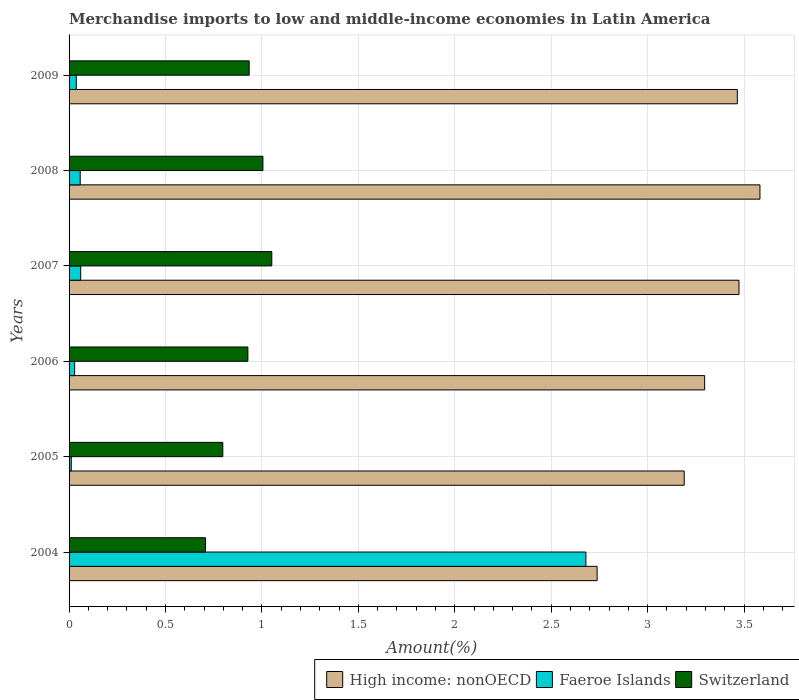How many different coloured bars are there?
Offer a very short reply. 3. Are the number of bars on each tick of the Y-axis equal?
Make the answer very short. Yes. How many bars are there on the 6th tick from the bottom?
Your response must be concise. 3. What is the percentage of amount earned from merchandise imports in Faeroe Islands in 2006?
Ensure brevity in your answer.  0.03. Across all years, what is the maximum percentage of amount earned from merchandise imports in Faeroe Islands?
Ensure brevity in your answer.  2.68. Across all years, what is the minimum percentage of amount earned from merchandise imports in Switzerland?
Ensure brevity in your answer.  0.71. What is the total percentage of amount earned from merchandise imports in Faeroe Islands in the graph?
Provide a succinct answer. 2.88. What is the difference between the percentage of amount earned from merchandise imports in High income: nonOECD in 2004 and that in 2008?
Offer a terse response. -0.84. What is the difference between the percentage of amount earned from merchandise imports in Switzerland in 2004 and the percentage of amount earned from merchandise imports in Faeroe Islands in 2009?
Make the answer very short. 0.67. What is the average percentage of amount earned from merchandise imports in Faeroe Islands per year?
Give a very brief answer. 0.48. In the year 2008, what is the difference between the percentage of amount earned from merchandise imports in Switzerland and percentage of amount earned from merchandise imports in Faeroe Islands?
Provide a short and direct response. 0.95. What is the ratio of the percentage of amount earned from merchandise imports in High income: nonOECD in 2004 to that in 2008?
Ensure brevity in your answer.  0.76. Is the percentage of amount earned from merchandise imports in Switzerland in 2004 less than that in 2008?
Ensure brevity in your answer.  Yes. What is the difference between the highest and the second highest percentage of amount earned from merchandise imports in Faeroe Islands?
Your response must be concise. 2.62. What is the difference between the highest and the lowest percentage of amount earned from merchandise imports in Faeroe Islands?
Provide a succinct answer. 2.67. What does the 3rd bar from the top in 2009 represents?
Give a very brief answer. High income: nonOECD. What does the 3rd bar from the bottom in 2006 represents?
Offer a very short reply. Switzerland. Is it the case that in every year, the sum of the percentage of amount earned from merchandise imports in Switzerland and percentage of amount earned from merchandise imports in Faeroe Islands is greater than the percentage of amount earned from merchandise imports in High income: nonOECD?
Offer a very short reply. No. How many bars are there?
Your response must be concise. 18. Are all the bars in the graph horizontal?
Your response must be concise. Yes. What is the difference between two consecutive major ticks on the X-axis?
Your response must be concise. 0.5. Does the graph contain any zero values?
Keep it short and to the point. No. Does the graph contain grids?
Provide a short and direct response. Yes. How many legend labels are there?
Your answer should be compact. 3. What is the title of the graph?
Your response must be concise. Merchandise imports to low and middle-income economies in Latin America. Does "Madagascar" appear as one of the legend labels in the graph?
Ensure brevity in your answer.  No. What is the label or title of the X-axis?
Ensure brevity in your answer.  Amount(%). What is the Amount(%) of High income: nonOECD in 2004?
Make the answer very short. 2.74. What is the Amount(%) of Faeroe Islands in 2004?
Your response must be concise. 2.68. What is the Amount(%) of Switzerland in 2004?
Offer a very short reply. 0.71. What is the Amount(%) of High income: nonOECD in 2005?
Make the answer very short. 3.19. What is the Amount(%) in Faeroe Islands in 2005?
Provide a succinct answer. 0.01. What is the Amount(%) of Switzerland in 2005?
Your response must be concise. 0.8. What is the Amount(%) in High income: nonOECD in 2006?
Provide a succinct answer. 3.3. What is the Amount(%) of Faeroe Islands in 2006?
Make the answer very short. 0.03. What is the Amount(%) in Switzerland in 2006?
Give a very brief answer. 0.93. What is the Amount(%) of High income: nonOECD in 2007?
Your response must be concise. 3.47. What is the Amount(%) in Faeroe Islands in 2007?
Provide a short and direct response. 0.06. What is the Amount(%) of Switzerland in 2007?
Make the answer very short. 1.05. What is the Amount(%) of High income: nonOECD in 2008?
Your answer should be very brief. 3.58. What is the Amount(%) in Faeroe Islands in 2008?
Keep it short and to the point. 0.06. What is the Amount(%) of Switzerland in 2008?
Give a very brief answer. 1.01. What is the Amount(%) in High income: nonOECD in 2009?
Offer a terse response. 3.47. What is the Amount(%) in Faeroe Islands in 2009?
Make the answer very short. 0.04. What is the Amount(%) of Switzerland in 2009?
Offer a terse response. 0.93. Across all years, what is the maximum Amount(%) of High income: nonOECD?
Offer a terse response. 3.58. Across all years, what is the maximum Amount(%) in Faeroe Islands?
Keep it short and to the point. 2.68. Across all years, what is the maximum Amount(%) in Switzerland?
Your response must be concise. 1.05. Across all years, what is the minimum Amount(%) of High income: nonOECD?
Offer a terse response. 2.74. Across all years, what is the minimum Amount(%) in Faeroe Islands?
Your response must be concise. 0.01. Across all years, what is the minimum Amount(%) of Switzerland?
Keep it short and to the point. 0.71. What is the total Amount(%) in High income: nonOECD in the graph?
Offer a terse response. 19.75. What is the total Amount(%) in Faeroe Islands in the graph?
Your answer should be compact. 2.88. What is the total Amount(%) of Switzerland in the graph?
Your response must be concise. 5.42. What is the difference between the Amount(%) of High income: nonOECD in 2004 and that in 2005?
Give a very brief answer. -0.45. What is the difference between the Amount(%) of Faeroe Islands in 2004 and that in 2005?
Give a very brief answer. 2.67. What is the difference between the Amount(%) in Switzerland in 2004 and that in 2005?
Your answer should be very brief. -0.09. What is the difference between the Amount(%) of High income: nonOECD in 2004 and that in 2006?
Ensure brevity in your answer.  -0.56. What is the difference between the Amount(%) in Faeroe Islands in 2004 and that in 2006?
Ensure brevity in your answer.  2.65. What is the difference between the Amount(%) in Switzerland in 2004 and that in 2006?
Your response must be concise. -0.22. What is the difference between the Amount(%) of High income: nonOECD in 2004 and that in 2007?
Offer a terse response. -0.74. What is the difference between the Amount(%) of Faeroe Islands in 2004 and that in 2007?
Your response must be concise. 2.62. What is the difference between the Amount(%) in Switzerland in 2004 and that in 2007?
Make the answer very short. -0.34. What is the difference between the Amount(%) of High income: nonOECD in 2004 and that in 2008?
Offer a very short reply. -0.84. What is the difference between the Amount(%) of Faeroe Islands in 2004 and that in 2008?
Offer a very short reply. 2.62. What is the difference between the Amount(%) in Switzerland in 2004 and that in 2008?
Provide a succinct answer. -0.3. What is the difference between the Amount(%) of High income: nonOECD in 2004 and that in 2009?
Keep it short and to the point. -0.73. What is the difference between the Amount(%) in Faeroe Islands in 2004 and that in 2009?
Keep it short and to the point. 2.64. What is the difference between the Amount(%) of Switzerland in 2004 and that in 2009?
Make the answer very short. -0.23. What is the difference between the Amount(%) of High income: nonOECD in 2005 and that in 2006?
Give a very brief answer. -0.11. What is the difference between the Amount(%) in Faeroe Islands in 2005 and that in 2006?
Make the answer very short. -0.02. What is the difference between the Amount(%) of Switzerland in 2005 and that in 2006?
Your answer should be very brief. -0.13. What is the difference between the Amount(%) in High income: nonOECD in 2005 and that in 2007?
Offer a terse response. -0.28. What is the difference between the Amount(%) in Faeroe Islands in 2005 and that in 2007?
Offer a terse response. -0.05. What is the difference between the Amount(%) of Switzerland in 2005 and that in 2007?
Give a very brief answer. -0.25. What is the difference between the Amount(%) of High income: nonOECD in 2005 and that in 2008?
Offer a very short reply. -0.39. What is the difference between the Amount(%) of Faeroe Islands in 2005 and that in 2008?
Provide a short and direct response. -0.05. What is the difference between the Amount(%) in Switzerland in 2005 and that in 2008?
Offer a very short reply. -0.21. What is the difference between the Amount(%) of High income: nonOECD in 2005 and that in 2009?
Keep it short and to the point. -0.28. What is the difference between the Amount(%) in Faeroe Islands in 2005 and that in 2009?
Your response must be concise. -0.03. What is the difference between the Amount(%) in Switzerland in 2005 and that in 2009?
Make the answer very short. -0.14. What is the difference between the Amount(%) of High income: nonOECD in 2006 and that in 2007?
Your answer should be compact. -0.18. What is the difference between the Amount(%) in Faeroe Islands in 2006 and that in 2007?
Offer a terse response. -0.03. What is the difference between the Amount(%) in Switzerland in 2006 and that in 2007?
Your answer should be compact. -0.12. What is the difference between the Amount(%) of High income: nonOECD in 2006 and that in 2008?
Offer a very short reply. -0.29. What is the difference between the Amount(%) in Faeroe Islands in 2006 and that in 2008?
Keep it short and to the point. -0.03. What is the difference between the Amount(%) of Switzerland in 2006 and that in 2008?
Your answer should be very brief. -0.08. What is the difference between the Amount(%) of High income: nonOECD in 2006 and that in 2009?
Provide a short and direct response. -0.17. What is the difference between the Amount(%) in Faeroe Islands in 2006 and that in 2009?
Make the answer very short. -0.01. What is the difference between the Amount(%) of Switzerland in 2006 and that in 2009?
Keep it short and to the point. -0.01. What is the difference between the Amount(%) in High income: nonOECD in 2007 and that in 2008?
Make the answer very short. -0.11. What is the difference between the Amount(%) in Faeroe Islands in 2007 and that in 2008?
Provide a short and direct response. 0. What is the difference between the Amount(%) in Switzerland in 2007 and that in 2008?
Your answer should be compact. 0.05. What is the difference between the Amount(%) of High income: nonOECD in 2007 and that in 2009?
Provide a short and direct response. 0.01. What is the difference between the Amount(%) of Faeroe Islands in 2007 and that in 2009?
Keep it short and to the point. 0.02. What is the difference between the Amount(%) of Switzerland in 2007 and that in 2009?
Ensure brevity in your answer.  0.12. What is the difference between the Amount(%) of High income: nonOECD in 2008 and that in 2009?
Your response must be concise. 0.12. What is the difference between the Amount(%) in Faeroe Islands in 2008 and that in 2009?
Ensure brevity in your answer.  0.02. What is the difference between the Amount(%) of Switzerland in 2008 and that in 2009?
Make the answer very short. 0.07. What is the difference between the Amount(%) of High income: nonOECD in 2004 and the Amount(%) of Faeroe Islands in 2005?
Make the answer very short. 2.73. What is the difference between the Amount(%) in High income: nonOECD in 2004 and the Amount(%) in Switzerland in 2005?
Your response must be concise. 1.94. What is the difference between the Amount(%) in Faeroe Islands in 2004 and the Amount(%) in Switzerland in 2005?
Provide a short and direct response. 1.88. What is the difference between the Amount(%) in High income: nonOECD in 2004 and the Amount(%) in Faeroe Islands in 2006?
Your answer should be very brief. 2.71. What is the difference between the Amount(%) in High income: nonOECD in 2004 and the Amount(%) in Switzerland in 2006?
Provide a succinct answer. 1.81. What is the difference between the Amount(%) of Faeroe Islands in 2004 and the Amount(%) of Switzerland in 2006?
Offer a terse response. 1.75. What is the difference between the Amount(%) in High income: nonOECD in 2004 and the Amount(%) in Faeroe Islands in 2007?
Provide a short and direct response. 2.68. What is the difference between the Amount(%) in High income: nonOECD in 2004 and the Amount(%) in Switzerland in 2007?
Your answer should be compact. 1.69. What is the difference between the Amount(%) in Faeroe Islands in 2004 and the Amount(%) in Switzerland in 2007?
Keep it short and to the point. 1.63. What is the difference between the Amount(%) of High income: nonOECD in 2004 and the Amount(%) of Faeroe Islands in 2008?
Your response must be concise. 2.68. What is the difference between the Amount(%) in High income: nonOECD in 2004 and the Amount(%) in Switzerland in 2008?
Your answer should be compact. 1.73. What is the difference between the Amount(%) of Faeroe Islands in 2004 and the Amount(%) of Switzerland in 2008?
Make the answer very short. 1.67. What is the difference between the Amount(%) in High income: nonOECD in 2004 and the Amount(%) in Faeroe Islands in 2009?
Provide a succinct answer. 2.7. What is the difference between the Amount(%) of High income: nonOECD in 2004 and the Amount(%) of Switzerland in 2009?
Your response must be concise. 1.8. What is the difference between the Amount(%) of Faeroe Islands in 2004 and the Amount(%) of Switzerland in 2009?
Your response must be concise. 1.75. What is the difference between the Amount(%) of High income: nonOECD in 2005 and the Amount(%) of Faeroe Islands in 2006?
Provide a short and direct response. 3.16. What is the difference between the Amount(%) of High income: nonOECD in 2005 and the Amount(%) of Switzerland in 2006?
Keep it short and to the point. 2.26. What is the difference between the Amount(%) of Faeroe Islands in 2005 and the Amount(%) of Switzerland in 2006?
Make the answer very short. -0.92. What is the difference between the Amount(%) in High income: nonOECD in 2005 and the Amount(%) in Faeroe Islands in 2007?
Provide a short and direct response. 3.13. What is the difference between the Amount(%) of High income: nonOECD in 2005 and the Amount(%) of Switzerland in 2007?
Your response must be concise. 2.14. What is the difference between the Amount(%) of Faeroe Islands in 2005 and the Amount(%) of Switzerland in 2007?
Your response must be concise. -1.04. What is the difference between the Amount(%) in High income: nonOECD in 2005 and the Amount(%) in Faeroe Islands in 2008?
Provide a succinct answer. 3.13. What is the difference between the Amount(%) of High income: nonOECD in 2005 and the Amount(%) of Switzerland in 2008?
Give a very brief answer. 2.18. What is the difference between the Amount(%) of Faeroe Islands in 2005 and the Amount(%) of Switzerland in 2008?
Ensure brevity in your answer.  -0.99. What is the difference between the Amount(%) in High income: nonOECD in 2005 and the Amount(%) in Faeroe Islands in 2009?
Give a very brief answer. 3.15. What is the difference between the Amount(%) of High income: nonOECD in 2005 and the Amount(%) of Switzerland in 2009?
Your response must be concise. 2.26. What is the difference between the Amount(%) of Faeroe Islands in 2005 and the Amount(%) of Switzerland in 2009?
Your response must be concise. -0.92. What is the difference between the Amount(%) in High income: nonOECD in 2006 and the Amount(%) in Faeroe Islands in 2007?
Your answer should be very brief. 3.24. What is the difference between the Amount(%) in High income: nonOECD in 2006 and the Amount(%) in Switzerland in 2007?
Your answer should be very brief. 2.24. What is the difference between the Amount(%) in Faeroe Islands in 2006 and the Amount(%) in Switzerland in 2007?
Offer a very short reply. -1.02. What is the difference between the Amount(%) of High income: nonOECD in 2006 and the Amount(%) of Faeroe Islands in 2008?
Offer a terse response. 3.24. What is the difference between the Amount(%) of High income: nonOECD in 2006 and the Amount(%) of Switzerland in 2008?
Your answer should be very brief. 2.29. What is the difference between the Amount(%) in Faeroe Islands in 2006 and the Amount(%) in Switzerland in 2008?
Provide a short and direct response. -0.98. What is the difference between the Amount(%) in High income: nonOECD in 2006 and the Amount(%) in Faeroe Islands in 2009?
Keep it short and to the point. 3.26. What is the difference between the Amount(%) in High income: nonOECD in 2006 and the Amount(%) in Switzerland in 2009?
Make the answer very short. 2.36. What is the difference between the Amount(%) of Faeroe Islands in 2006 and the Amount(%) of Switzerland in 2009?
Provide a succinct answer. -0.91. What is the difference between the Amount(%) of High income: nonOECD in 2007 and the Amount(%) of Faeroe Islands in 2008?
Provide a succinct answer. 3.42. What is the difference between the Amount(%) in High income: nonOECD in 2007 and the Amount(%) in Switzerland in 2008?
Provide a succinct answer. 2.47. What is the difference between the Amount(%) in Faeroe Islands in 2007 and the Amount(%) in Switzerland in 2008?
Ensure brevity in your answer.  -0.94. What is the difference between the Amount(%) of High income: nonOECD in 2007 and the Amount(%) of Faeroe Islands in 2009?
Provide a short and direct response. 3.44. What is the difference between the Amount(%) of High income: nonOECD in 2007 and the Amount(%) of Switzerland in 2009?
Provide a short and direct response. 2.54. What is the difference between the Amount(%) of Faeroe Islands in 2007 and the Amount(%) of Switzerland in 2009?
Provide a short and direct response. -0.87. What is the difference between the Amount(%) in High income: nonOECD in 2008 and the Amount(%) in Faeroe Islands in 2009?
Offer a terse response. 3.55. What is the difference between the Amount(%) of High income: nonOECD in 2008 and the Amount(%) of Switzerland in 2009?
Give a very brief answer. 2.65. What is the difference between the Amount(%) of Faeroe Islands in 2008 and the Amount(%) of Switzerland in 2009?
Give a very brief answer. -0.88. What is the average Amount(%) in High income: nonOECD per year?
Give a very brief answer. 3.29. What is the average Amount(%) of Faeroe Islands per year?
Give a very brief answer. 0.48. What is the average Amount(%) in Switzerland per year?
Your answer should be compact. 0.9. In the year 2004, what is the difference between the Amount(%) of High income: nonOECD and Amount(%) of Faeroe Islands?
Your answer should be compact. 0.06. In the year 2004, what is the difference between the Amount(%) of High income: nonOECD and Amount(%) of Switzerland?
Ensure brevity in your answer.  2.03. In the year 2004, what is the difference between the Amount(%) of Faeroe Islands and Amount(%) of Switzerland?
Offer a very short reply. 1.97. In the year 2005, what is the difference between the Amount(%) in High income: nonOECD and Amount(%) in Faeroe Islands?
Make the answer very short. 3.18. In the year 2005, what is the difference between the Amount(%) in High income: nonOECD and Amount(%) in Switzerland?
Ensure brevity in your answer.  2.39. In the year 2005, what is the difference between the Amount(%) in Faeroe Islands and Amount(%) in Switzerland?
Offer a terse response. -0.79. In the year 2006, what is the difference between the Amount(%) in High income: nonOECD and Amount(%) in Faeroe Islands?
Offer a very short reply. 3.27. In the year 2006, what is the difference between the Amount(%) of High income: nonOECD and Amount(%) of Switzerland?
Ensure brevity in your answer.  2.37. In the year 2006, what is the difference between the Amount(%) in Faeroe Islands and Amount(%) in Switzerland?
Keep it short and to the point. -0.9. In the year 2007, what is the difference between the Amount(%) of High income: nonOECD and Amount(%) of Faeroe Islands?
Provide a short and direct response. 3.41. In the year 2007, what is the difference between the Amount(%) of High income: nonOECD and Amount(%) of Switzerland?
Offer a terse response. 2.42. In the year 2007, what is the difference between the Amount(%) in Faeroe Islands and Amount(%) in Switzerland?
Your response must be concise. -0.99. In the year 2008, what is the difference between the Amount(%) of High income: nonOECD and Amount(%) of Faeroe Islands?
Give a very brief answer. 3.52. In the year 2008, what is the difference between the Amount(%) of High income: nonOECD and Amount(%) of Switzerland?
Your answer should be very brief. 2.58. In the year 2008, what is the difference between the Amount(%) in Faeroe Islands and Amount(%) in Switzerland?
Make the answer very short. -0.95. In the year 2009, what is the difference between the Amount(%) in High income: nonOECD and Amount(%) in Faeroe Islands?
Your answer should be compact. 3.43. In the year 2009, what is the difference between the Amount(%) in High income: nonOECD and Amount(%) in Switzerland?
Give a very brief answer. 2.53. In the year 2009, what is the difference between the Amount(%) in Faeroe Islands and Amount(%) in Switzerland?
Provide a short and direct response. -0.9. What is the ratio of the Amount(%) in High income: nonOECD in 2004 to that in 2005?
Offer a terse response. 0.86. What is the ratio of the Amount(%) of Faeroe Islands in 2004 to that in 2005?
Your response must be concise. 233.91. What is the ratio of the Amount(%) of Switzerland in 2004 to that in 2005?
Your answer should be compact. 0.89. What is the ratio of the Amount(%) of High income: nonOECD in 2004 to that in 2006?
Your answer should be very brief. 0.83. What is the ratio of the Amount(%) of Faeroe Islands in 2004 to that in 2006?
Make the answer very short. 92.46. What is the ratio of the Amount(%) of Switzerland in 2004 to that in 2006?
Offer a terse response. 0.76. What is the ratio of the Amount(%) of High income: nonOECD in 2004 to that in 2007?
Make the answer very short. 0.79. What is the ratio of the Amount(%) of Faeroe Islands in 2004 to that in 2007?
Give a very brief answer. 44.5. What is the ratio of the Amount(%) in Switzerland in 2004 to that in 2007?
Your response must be concise. 0.67. What is the ratio of the Amount(%) of High income: nonOECD in 2004 to that in 2008?
Your response must be concise. 0.76. What is the ratio of the Amount(%) in Faeroe Islands in 2004 to that in 2008?
Make the answer very short. 46.38. What is the ratio of the Amount(%) in Switzerland in 2004 to that in 2008?
Ensure brevity in your answer.  0.7. What is the ratio of the Amount(%) of High income: nonOECD in 2004 to that in 2009?
Provide a short and direct response. 0.79. What is the ratio of the Amount(%) in Faeroe Islands in 2004 to that in 2009?
Give a very brief answer. 71.55. What is the ratio of the Amount(%) of Switzerland in 2004 to that in 2009?
Keep it short and to the point. 0.76. What is the ratio of the Amount(%) of High income: nonOECD in 2005 to that in 2006?
Your response must be concise. 0.97. What is the ratio of the Amount(%) in Faeroe Islands in 2005 to that in 2006?
Offer a terse response. 0.4. What is the ratio of the Amount(%) in Switzerland in 2005 to that in 2006?
Offer a very short reply. 0.86. What is the ratio of the Amount(%) of High income: nonOECD in 2005 to that in 2007?
Offer a terse response. 0.92. What is the ratio of the Amount(%) in Faeroe Islands in 2005 to that in 2007?
Keep it short and to the point. 0.19. What is the ratio of the Amount(%) of Switzerland in 2005 to that in 2007?
Provide a short and direct response. 0.76. What is the ratio of the Amount(%) of High income: nonOECD in 2005 to that in 2008?
Offer a very short reply. 0.89. What is the ratio of the Amount(%) of Faeroe Islands in 2005 to that in 2008?
Offer a terse response. 0.2. What is the ratio of the Amount(%) in Switzerland in 2005 to that in 2008?
Offer a terse response. 0.79. What is the ratio of the Amount(%) of High income: nonOECD in 2005 to that in 2009?
Your response must be concise. 0.92. What is the ratio of the Amount(%) of Faeroe Islands in 2005 to that in 2009?
Make the answer very short. 0.31. What is the ratio of the Amount(%) of Switzerland in 2005 to that in 2009?
Your response must be concise. 0.85. What is the ratio of the Amount(%) of High income: nonOECD in 2006 to that in 2007?
Offer a terse response. 0.95. What is the ratio of the Amount(%) of Faeroe Islands in 2006 to that in 2007?
Offer a very short reply. 0.48. What is the ratio of the Amount(%) of Switzerland in 2006 to that in 2007?
Give a very brief answer. 0.88. What is the ratio of the Amount(%) of Faeroe Islands in 2006 to that in 2008?
Your answer should be compact. 0.5. What is the ratio of the Amount(%) of Switzerland in 2006 to that in 2008?
Your response must be concise. 0.92. What is the ratio of the Amount(%) in High income: nonOECD in 2006 to that in 2009?
Ensure brevity in your answer.  0.95. What is the ratio of the Amount(%) of Faeroe Islands in 2006 to that in 2009?
Keep it short and to the point. 0.77. What is the ratio of the Amount(%) of Switzerland in 2006 to that in 2009?
Keep it short and to the point. 0.99. What is the ratio of the Amount(%) in High income: nonOECD in 2007 to that in 2008?
Offer a very short reply. 0.97. What is the ratio of the Amount(%) in Faeroe Islands in 2007 to that in 2008?
Your answer should be very brief. 1.04. What is the ratio of the Amount(%) of Switzerland in 2007 to that in 2008?
Provide a short and direct response. 1.05. What is the ratio of the Amount(%) in Faeroe Islands in 2007 to that in 2009?
Provide a succinct answer. 1.61. What is the ratio of the Amount(%) in Switzerland in 2007 to that in 2009?
Your answer should be very brief. 1.13. What is the ratio of the Amount(%) in High income: nonOECD in 2008 to that in 2009?
Your response must be concise. 1.03. What is the ratio of the Amount(%) of Faeroe Islands in 2008 to that in 2009?
Your answer should be compact. 1.54. What is the ratio of the Amount(%) in Switzerland in 2008 to that in 2009?
Keep it short and to the point. 1.08. What is the difference between the highest and the second highest Amount(%) in High income: nonOECD?
Keep it short and to the point. 0.11. What is the difference between the highest and the second highest Amount(%) in Faeroe Islands?
Make the answer very short. 2.62. What is the difference between the highest and the second highest Amount(%) in Switzerland?
Your answer should be compact. 0.05. What is the difference between the highest and the lowest Amount(%) of High income: nonOECD?
Your answer should be compact. 0.84. What is the difference between the highest and the lowest Amount(%) of Faeroe Islands?
Provide a short and direct response. 2.67. What is the difference between the highest and the lowest Amount(%) of Switzerland?
Offer a very short reply. 0.34. 